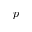<formula> <loc_0><loc_0><loc_500><loc_500>p</formula> 